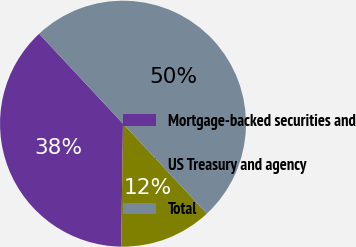Convert chart to OTSL. <chart><loc_0><loc_0><loc_500><loc_500><pie_chart><fcel>Mortgage-backed securities and<fcel>US Treasury and agency<fcel>Total<nl><fcel>37.82%<fcel>12.18%<fcel>50.0%<nl></chart> 